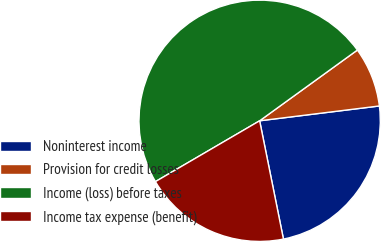Convert chart. <chart><loc_0><loc_0><loc_500><loc_500><pie_chart><fcel>Noninterest income<fcel>Provision for credit losses<fcel>Income (loss) before taxes<fcel>Income tax expense (benefit)<nl><fcel>23.8%<fcel>8.01%<fcel>48.44%<fcel>19.75%<nl></chart> 